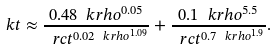<formula> <loc_0><loc_0><loc_500><loc_500>\ k t \approx \frac { 0 . 4 8 \ k r h o ^ { 0 . 0 5 } } { \ r c t ^ { 0 . 0 2 \ k r h o ^ { 1 . 0 9 } } } + \frac { 0 . 1 \ k r h o ^ { 5 . 5 } } { \ r c t ^ { 0 . 7 \ k r h o ^ { 1 . 9 } } } .</formula> 